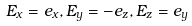<formula> <loc_0><loc_0><loc_500><loc_500>E _ { x } = e _ { x } , E _ { y } = - e _ { z } , E _ { z } = e _ { y }</formula> 